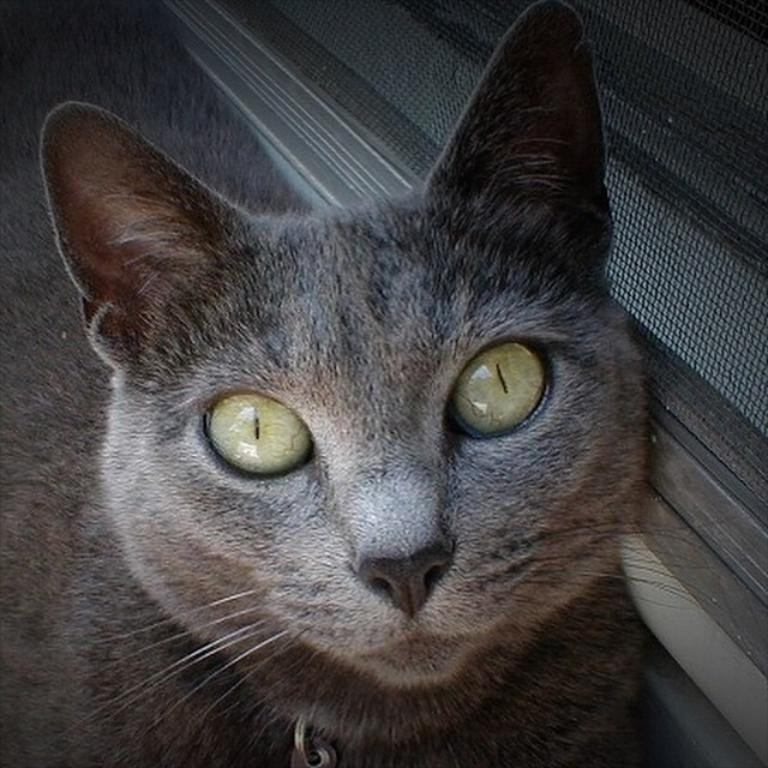What type of animal is present in the image? There is a cat in the image. Can you describe the color of the cat? The cat is black in color. What type of yoke can be seen in the image? There is no yoke present in the image; it features a black cat. 